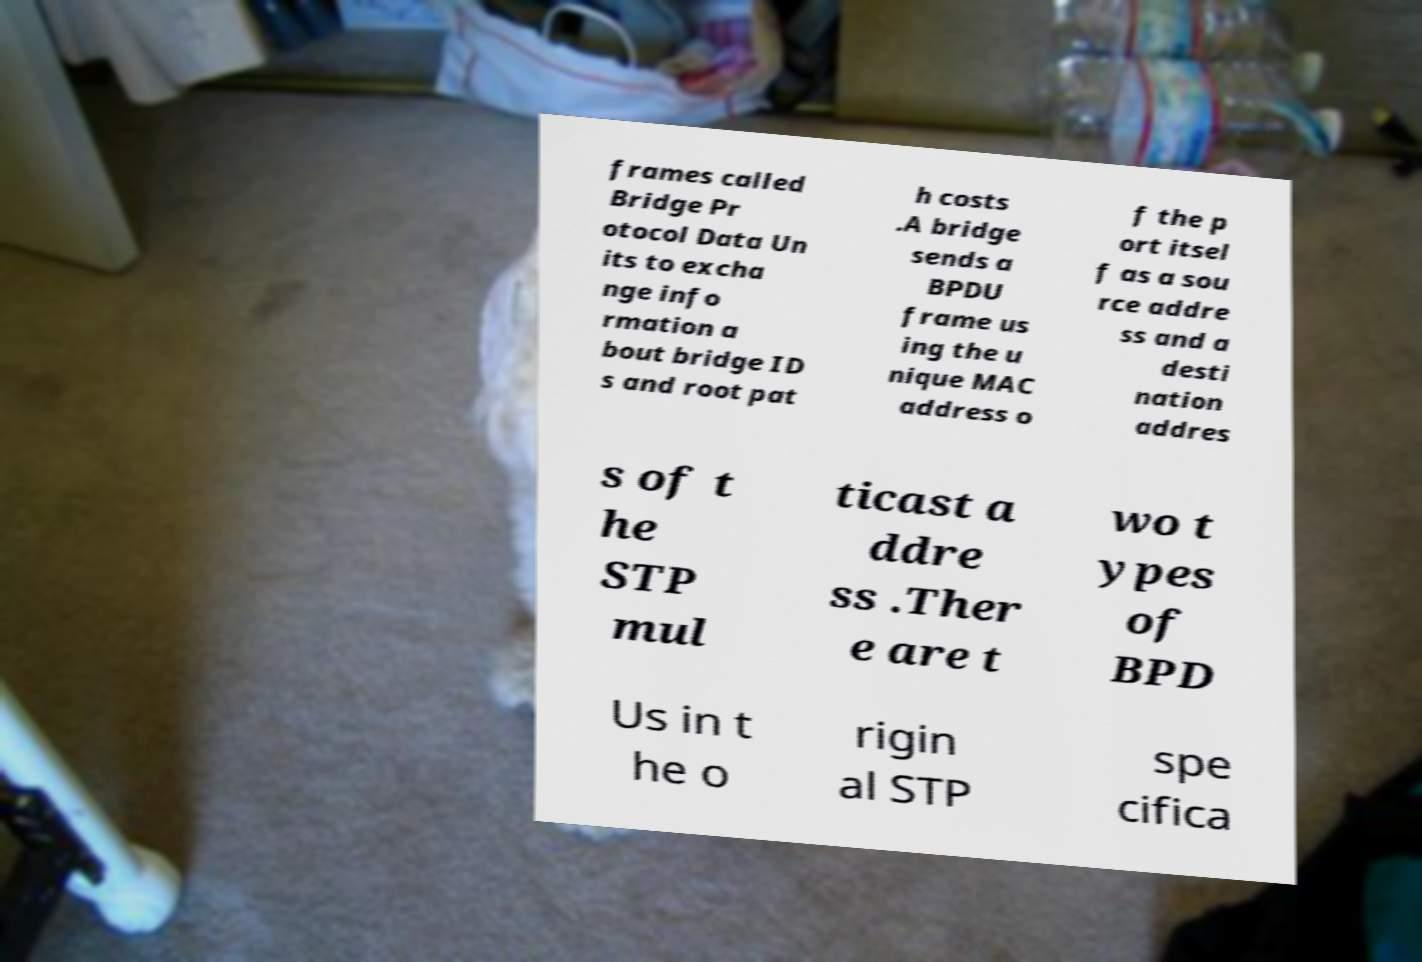Could you extract and type out the text from this image? frames called Bridge Pr otocol Data Un its to excha nge info rmation a bout bridge ID s and root pat h costs .A bridge sends a BPDU frame us ing the u nique MAC address o f the p ort itsel f as a sou rce addre ss and a desti nation addres s of t he STP mul ticast a ddre ss .Ther e are t wo t ypes of BPD Us in t he o rigin al STP spe cifica 